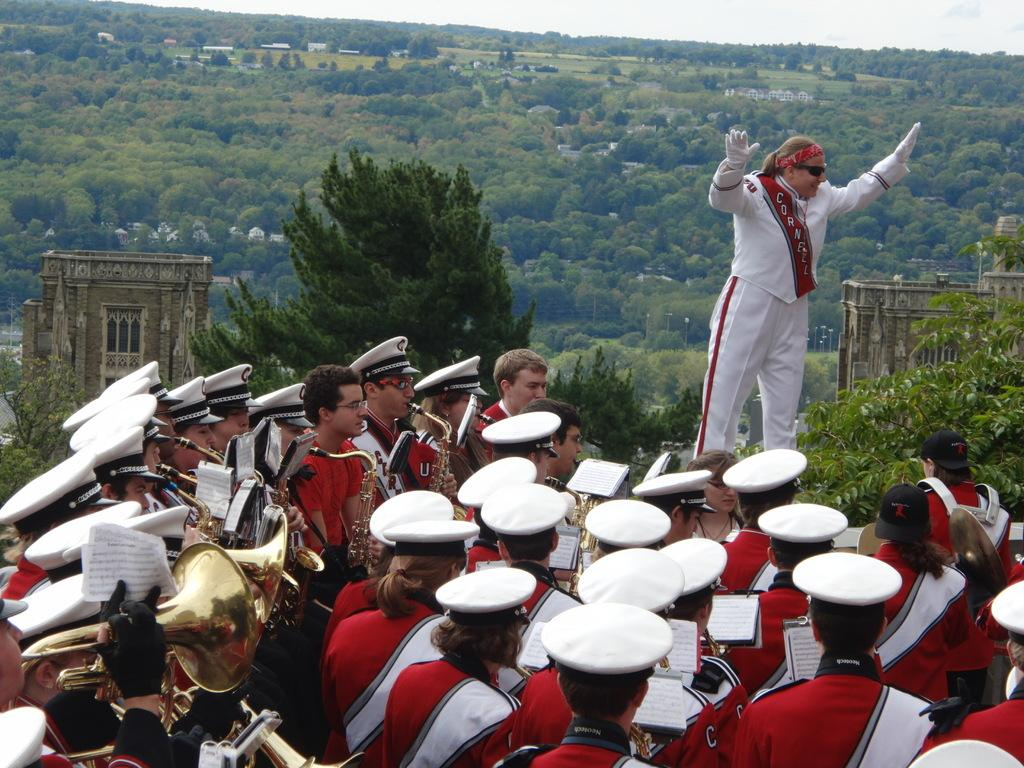How many persons are in the image? There are persons in the image, but the exact number is not specified. What are some of the persons doing in the image? Some of the persons are holding musical instruments. What can be seen in the background of the image? There are trees, buildings, and clouds in the sky in the background of the image. What type of stick is being used by the visitor in the image? There is no visitor present in the image, and therefore no stick being used. What is the base of the musical instrument being played by the person in the image? The facts do not specify the type of musical instrument being played, so we cannot determine the base of the instrument. 